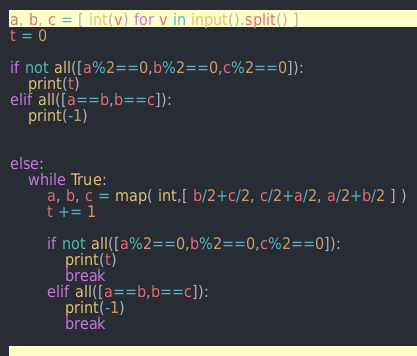<code> <loc_0><loc_0><loc_500><loc_500><_Python_>a, b, c = [ int(v) for v in input().split() ]
t = 0

if not all([a%2==0,b%2==0,c%2==0]):
    print(t)
elif all([a==b,b==c]):
    print(-1)


else:
    while True:
        a, b, c = map( int,[ b/2+c/2, c/2+a/2, a/2+b/2 ] )
        t += 1

        if not all([a%2==0,b%2==0,c%2==0]):
            print(t)
            break
        elif all([a==b,b==c]):
            print(-1)
            break
        </code> 